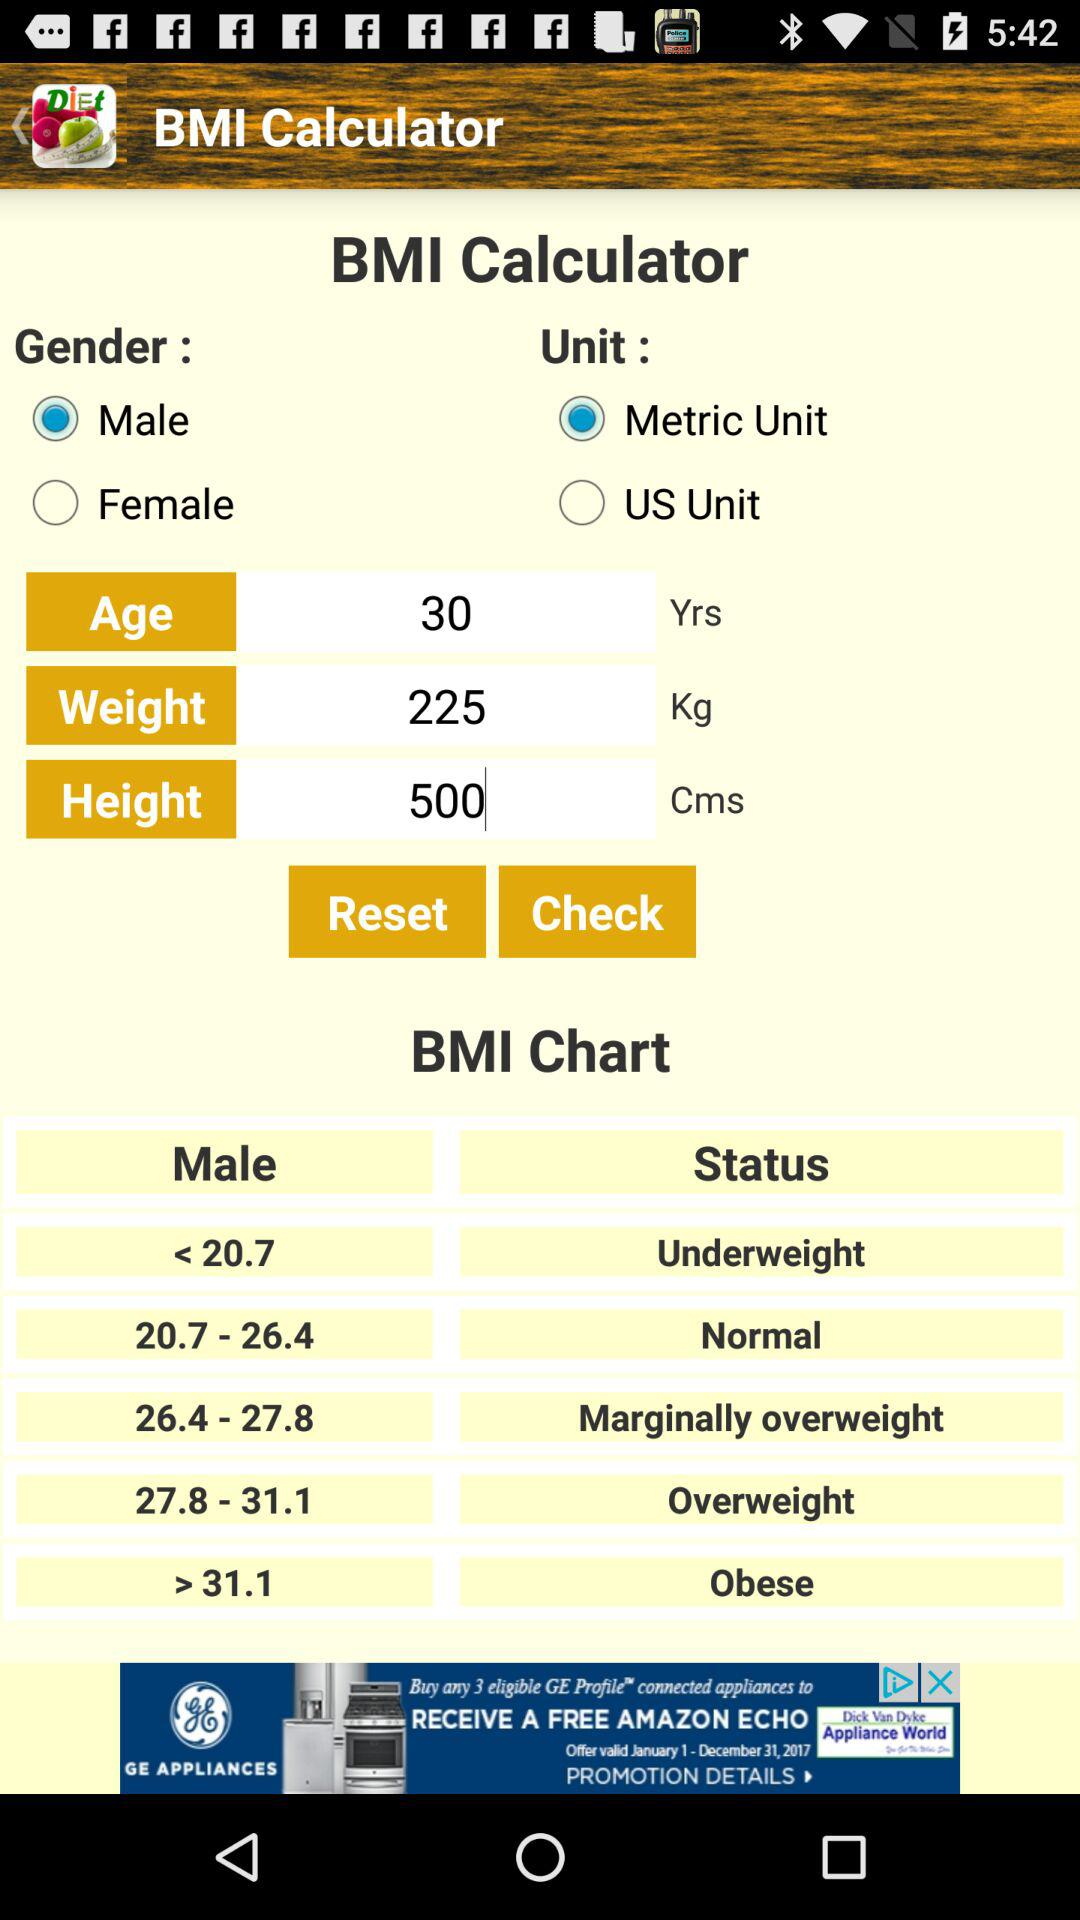What is the status of a male with a BMI ranging from 26.4 to 27.8? The status is "Marginally overweight". 